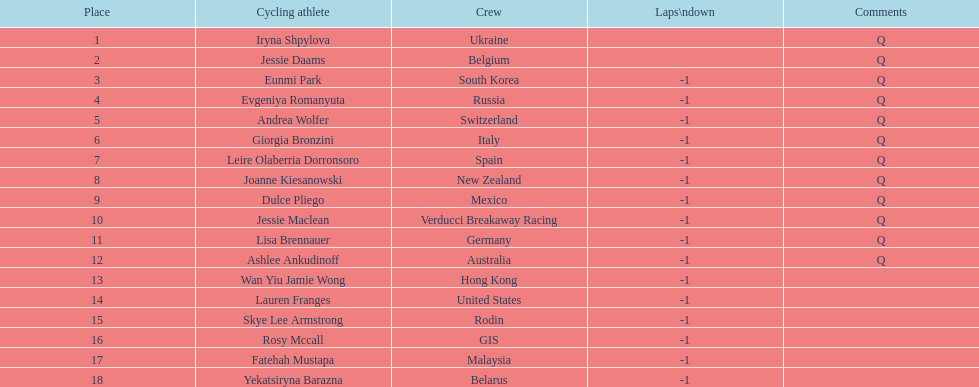Could you parse the entire table? {'header': ['Place', 'Cycling athlete', 'Crew', 'Laps\\ndown', 'Comments'], 'rows': [['1', 'Iryna Shpylova', 'Ukraine', '', 'Q'], ['2', 'Jessie Daams', 'Belgium', '', 'Q'], ['3', 'Eunmi Park', 'South Korea', '-1', 'Q'], ['4', 'Evgeniya Romanyuta', 'Russia', '-1', 'Q'], ['5', 'Andrea Wolfer', 'Switzerland', '-1', 'Q'], ['6', 'Giorgia Bronzini', 'Italy', '-1', 'Q'], ['7', 'Leire Olaberria Dorronsoro', 'Spain', '-1', 'Q'], ['8', 'Joanne Kiesanowski', 'New Zealand', '-1', 'Q'], ['9', 'Dulce Pliego', 'Mexico', '-1', 'Q'], ['10', 'Jessie Maclean', 'Verducci Breakaway Racing', '-1', 'Q'], ['11', 'Lisa Brennauer', 'Germany', '-1', 'Q'], ['12', 'Ashlee Ankudinoff', 'Australia', '-1', 'Q'], ['13', 'Wan Yiu Jamie Wong', 'Hong Kong', '-1', ''], ['14', 'Lauren Franges', 'United States', '-1', ''], ['15', 'Skye Lee Armstrong', 'Rodin', '-1', ''], ['16', 'Rosy Mccall', 'GIS', '-1', ''], ['17', 'Fatehah Mustapa', 'Malaysia', '-1', ''], ['18', 'Yekatsiryna Barazna', 'Belarus', '-1', '']]} Who is the last cyclist listed? Yekatsiryna Barazna. 